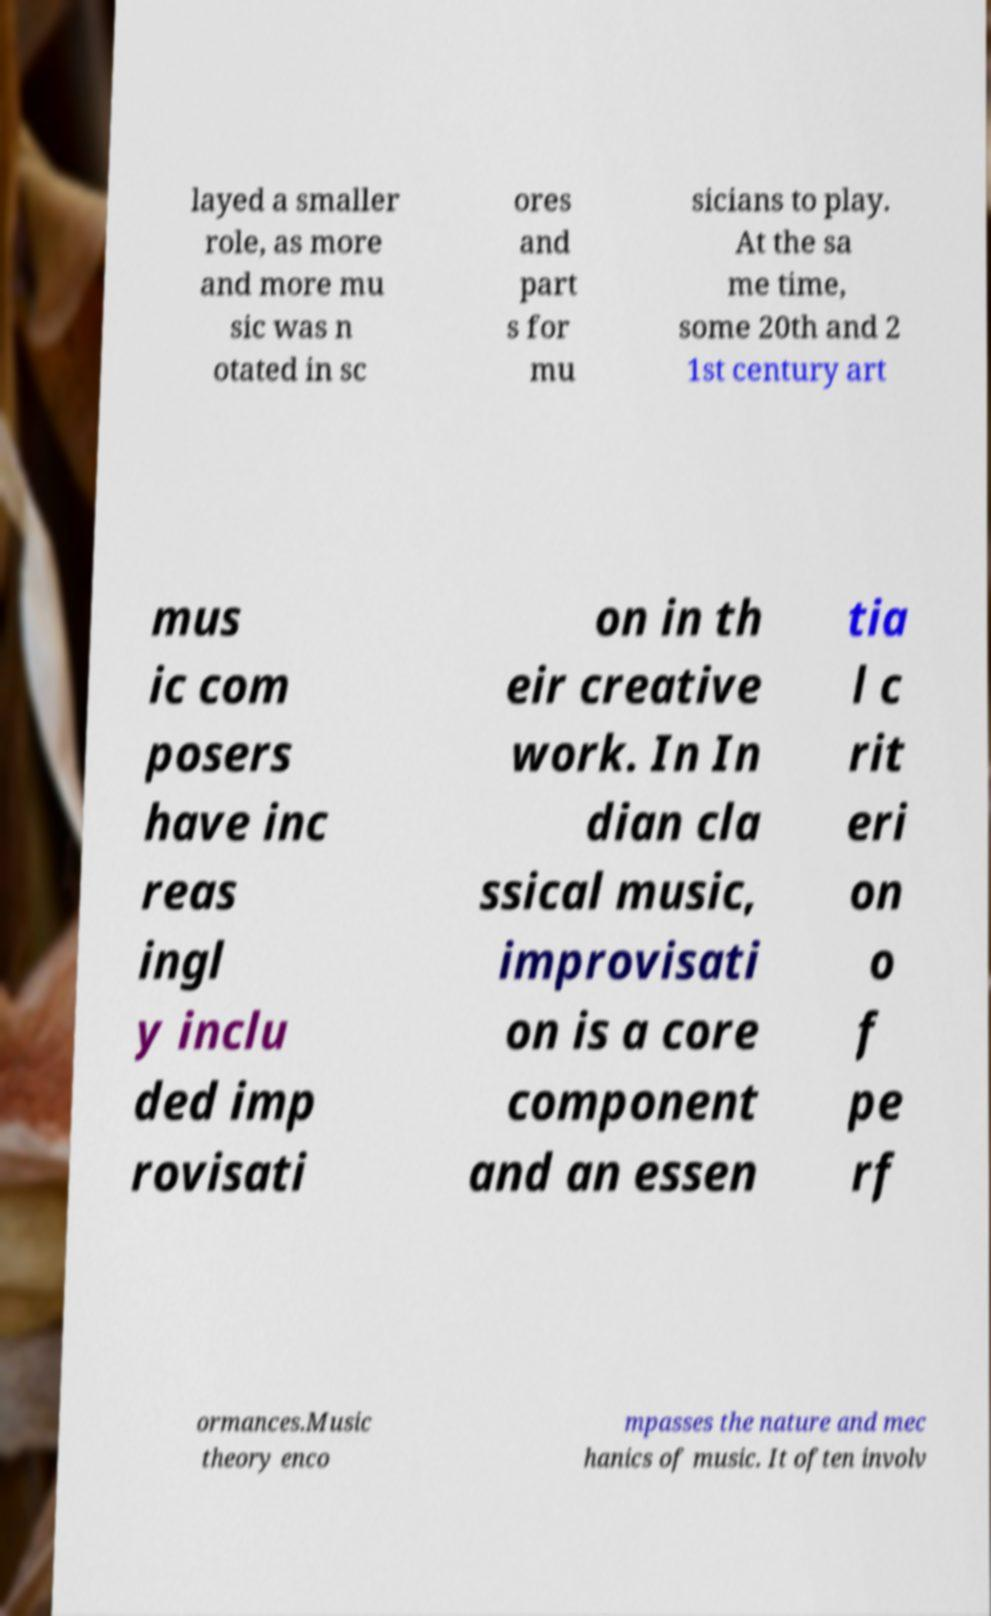I need the written content from this picture converted into text. Can you do that? layed a smaller role, as more and more mu sic was n otated in sc ores and part s for mu sicians to play. At the sa me time, some 20th and 2 1st century art mus ic com posers have inc reas ingl y inclu ded imp rovisati on in th eir creative work. In In dian cla ssical music, improvisati on is a core component and an essen tia l c rit eri on o f pe rf ormances.Music theory enco mpasses the nature and mec hanics of music. It often involv 